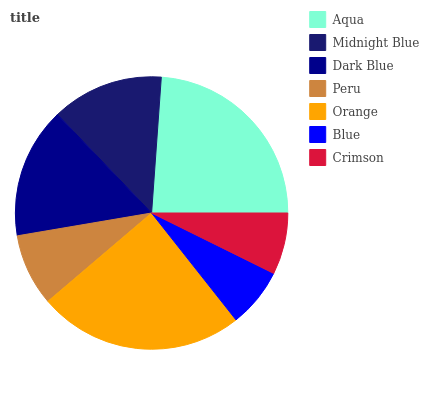Is Blue the minimum?
Answer yes or no. Yes. Is Orange the maximum?
Answer yes or no. Yes. Is Midnight Blue the minimum?
Answer yes or no. No. Is Midnight Blue the maximum?
Answer yes or no. No. Is Aqua greater than Midnight Blue?
Answer yes or no. Yes. Is Midnight Blue less than Aqua?
Answer yes or no. Yes. Is Midnight Blue greater than Aqua?
Answer yes or no. No. Is Aqua less than Midnight Blue?
Answer yes or no. No. Is Midnight Blue the high median?
Answer yes or no. Yes. Is Midnight Blue the low median?
Answer yes or no. Yes. Is Peru the high median?
Answer yes or no. No. Is Aqua the low median?
Answer yes or no. No. 